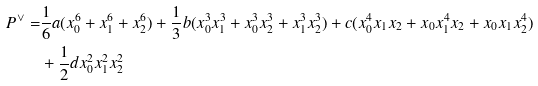Convert formula to latex. <formula><loc_0><loc_0><loc_500><loc_500>P ^ { \vee } = & \frac { 1 } { 6 } a ( x _ { 0 } ^ { 6 } + x _ { 1 } ^ { 6 } + x _ { 2 } ^ { 6 } ) + \frac { 1 } { 3 } b ( x _ { 0 } ^ { 3 } x _ { 1 } ^ { 3 } + x _ { 0 } ^ { 3 } x _ { 2 } ^ { 3 } + x _ { 1 } ^ { 3 } x _ { 2 } ^ { 3 } ) + c ( x _ { 0 } ^ { 4 } x _ { 1 } x _ { 2 } + x _ { 0 } x _ { 1 } ^ { 4 } x _ { 2 } + x _ { 0 } x _ { 1 } x _ { 2 } ^ { 4 } ) \\ & + \frac { 1 } { 2 } d x _ { 0 } ^ { 2 } x _ { 1 } ^ { 2 } x _ { 2 } ^ { 2 }</formula> 